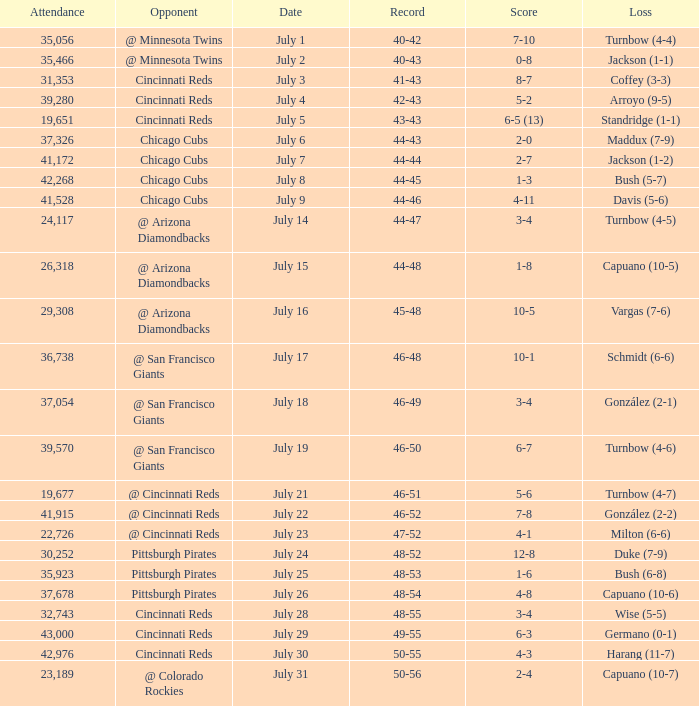What was the loss of the Brewers game when the record was 46-48? Schmidt (6-6). 